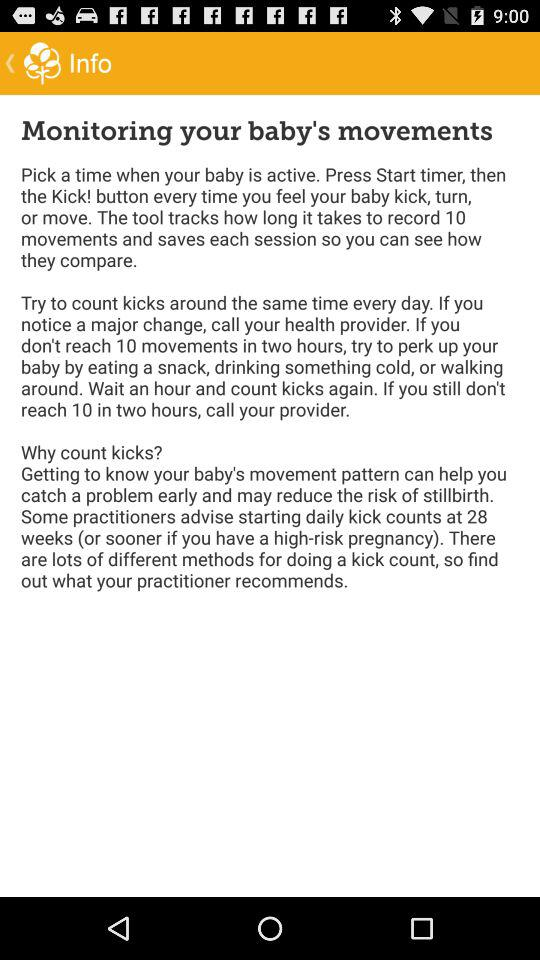How many movements need to be recorded? There are 10 movements that need to be recorded. 